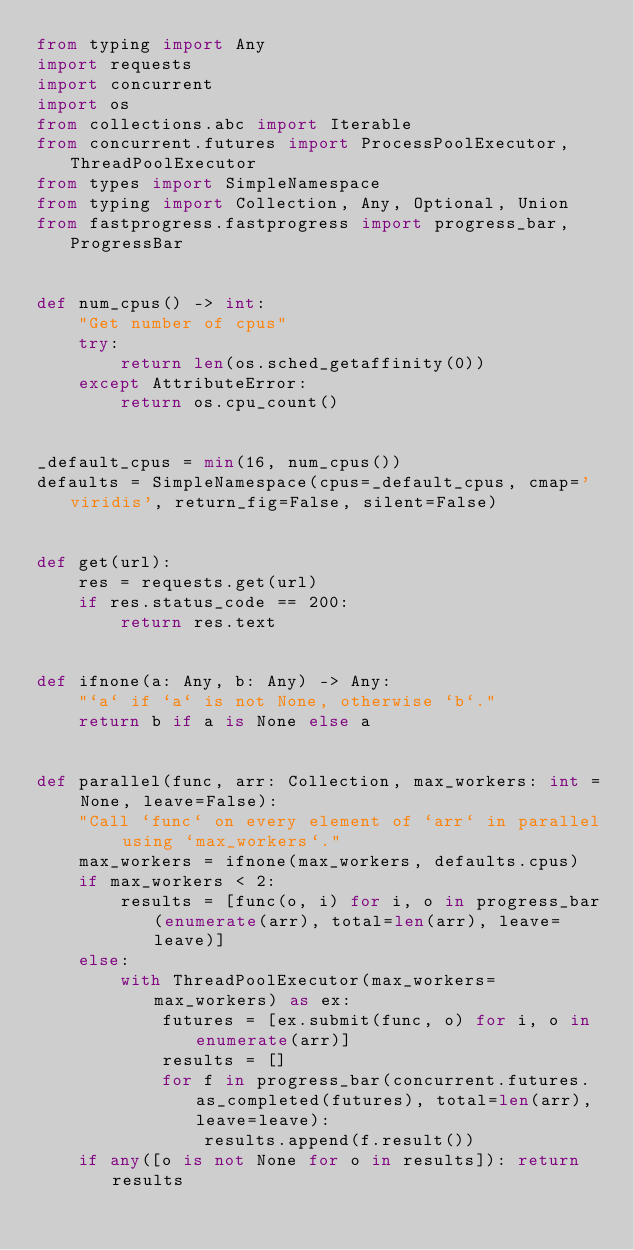<code> <loc_0><loc_0><loc_500><loc_500><_Python_>from typing import Any
import requests
import concurrent
import os
from collections.abc import Iterable
from concurrent.futures import ProcessPoolExecutor, ThreadPoolExecutor
from types import SimpleNamespace
from typing import Collection, Any, Optional, Union
from fastprogress.fastprogress import progress_bar, ProgressBar


def num_cpus() -> int:
    "Get number of cpus"
    try:
        return len(os.sched_getaffinity(0))
    except AttributeError:
        return os.cpu_count()


_default_cpus = min(16, num_cpus())
defaults = SimpleNamespace(cpus=_default_cpus, cmap='viridis', return_fig=False, silent=False)


def get(url):
    res = requests.get(url)
    if res.status_code == 200:
        return res.text


def ifnone(a: Any, b: Any) -> Any:
    "`a` if `a` is not None, otherwise `b`."
    return b if a is None else a


def parallel(func, arr: Collection, max_workers: int = None, leave=False):
    "Call `func` on every element of `arr` in parallel using `max_workers`."
    max_workers = ifnone(max_workers, defaults.cpus)
    if max_workers < 2:
        results = [func(o, i) for i, o in progress_bar(enumerate(arr), total=len(arr), leave=leave)]
    else:
        with ThreadPoolExecutor(max_workers=max_workers) as ex:
            futures = [ex.submit(func, o) for i, o in enumerate(arr)]
            results = []
            for f in progress_bar(concurrent.futures.as_completed(futures), total=len(arr), leave=leave):
                results.append(f.result())
    if any([o is not None for o in results]): return results</code> 